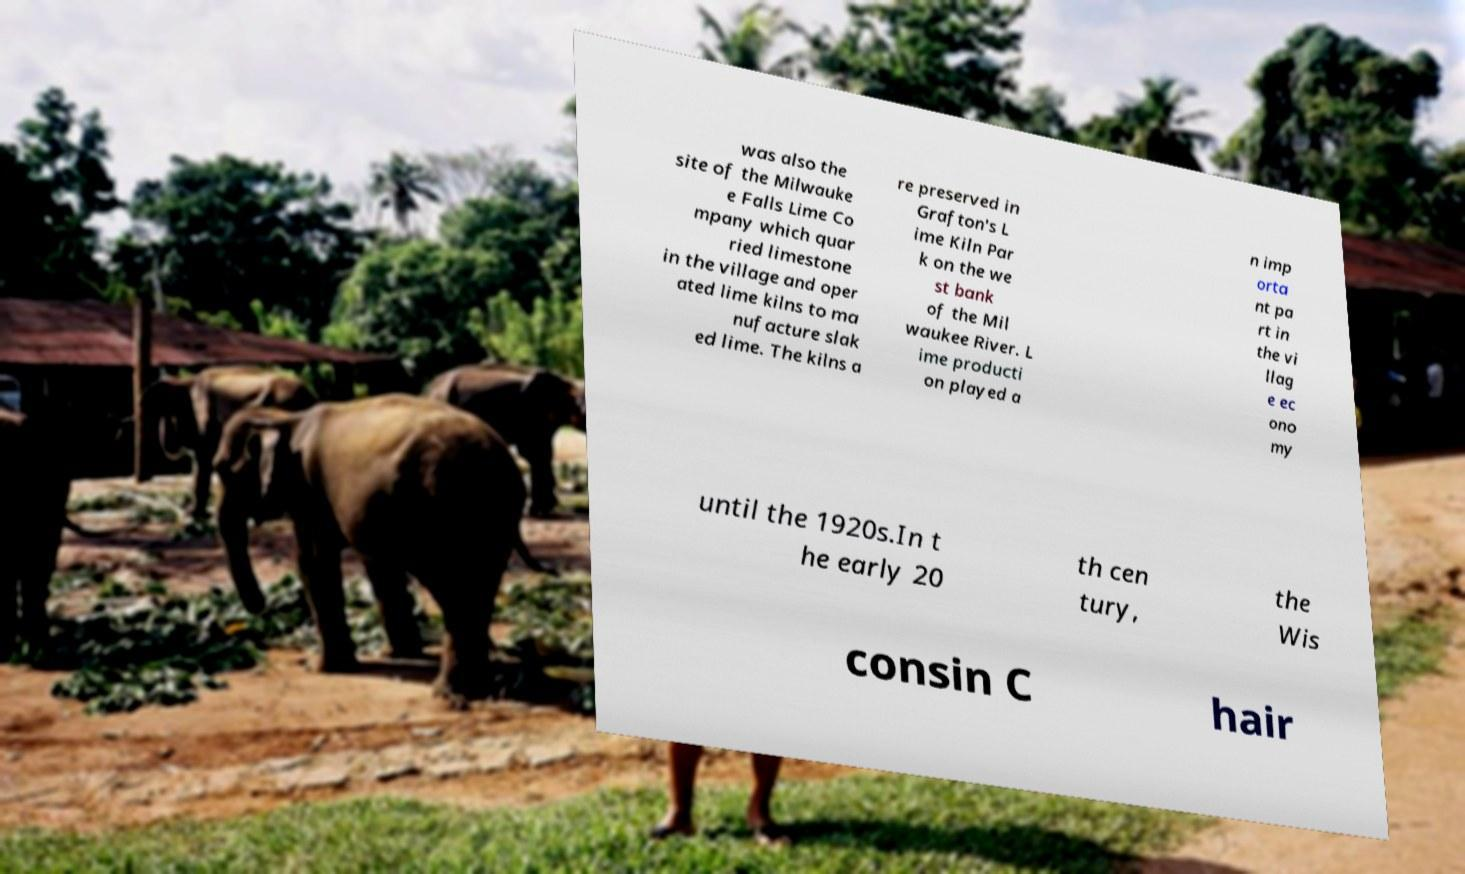Please read and relay the text visible in this image. What does it say? was also the site of the Milwauke e Falls Lime Co mpany which quar ried limestone in the village and oper ated lime kilns to ma nufacture slak ed lime. The kilns a re preserved in Grafton's L ime Kiln Par k on the we st bank of the Mil waukee River. L ime producti on played a n imp orta nt pa rt in the vi llag e ec ono my until the 1920s.In t he early 20 th cen tury, the Wis consin C hair 